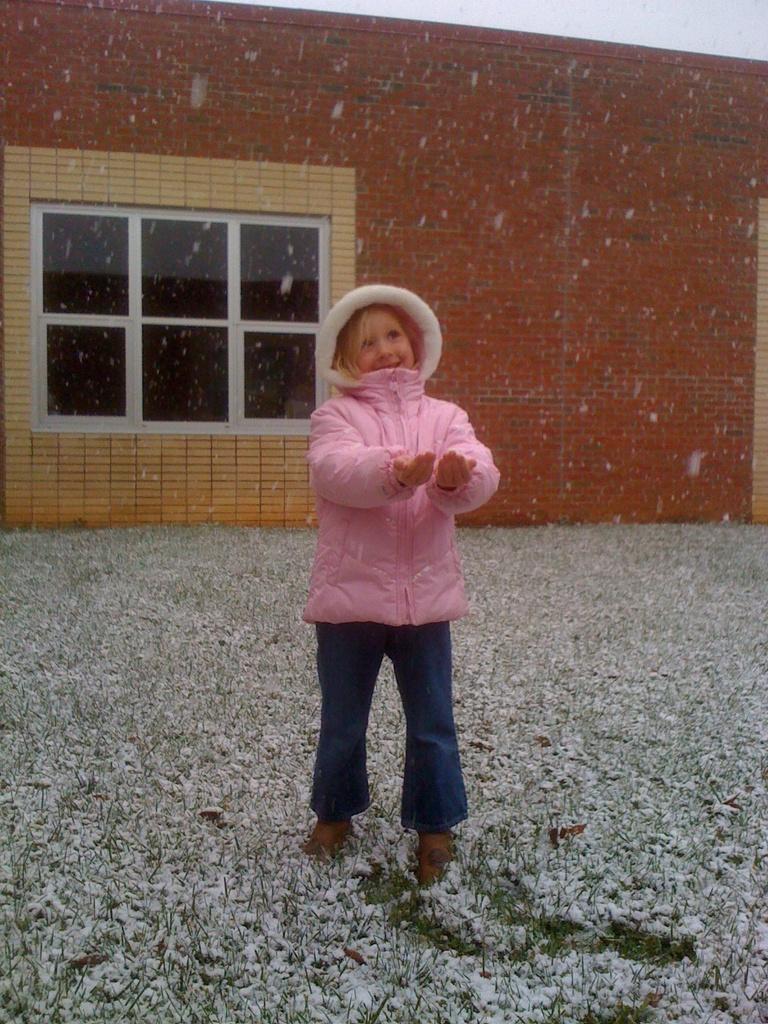How would you summarize this image in a sentence or two? In this image I can see a girl wearing pink jacket and blue jeans is standing on the ground and I can see some grass and the snow on the floor. In the background I can see the building and the window of the building. 